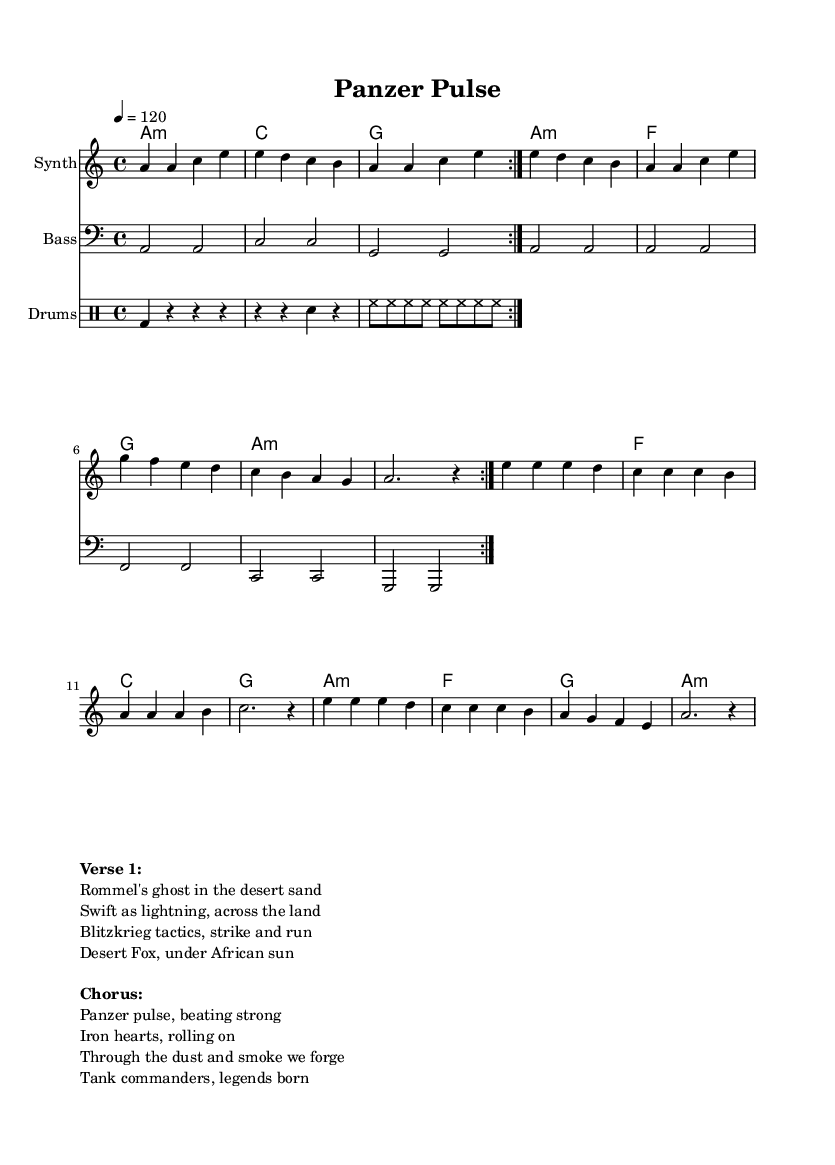What is the key signature of this music? The key signature shown in the score is A minor, which contains no sharps or flats. You can identify the key by looking at the initial part of the score where the key signature is indicated.
Answer: A minor What is the time signature of this music? The time signature indicated in the score is 4/4, which means there are four beats in a measure and the quarter note gets one beat. This is typically noted at the beginning of the score.
Answer: 4/4 What is the tempo marking of this music? The tempo marking is 120 beats per minute. This is indicated in the tempo directive at the beginning of the score, showing how fast the music should be played.
Answer: 120 How many volta sections are repeated in the melody? The melody section has a repeat marking that indicates it should be played twice. This means that the section is to be repeated, which is a common practice in pop music structure.
Answer: 2 What is the instrument name for the melody staff? The instrument name for the melody staff is "Synth." This is specified in the staff's header, indicating the type of sound or instrument being represented.
Answer: Synth Which historical figure is referenced in the first verse? The first verse mentions "Rommel," which refers to the famous German tank commander, Erwin Rommel, known for his tactical prowess during World War II. This is inferred from the lyrics provided.
Answer: Rommel How does the chorus describe the tank commanders? The chorus uses the phrase "Iron hearts," to depict the tank commanders, suggesting their strength and resilience in battle. This phrase captures the essence of their character as leaders during warfare.
Answer: Iron hearts 